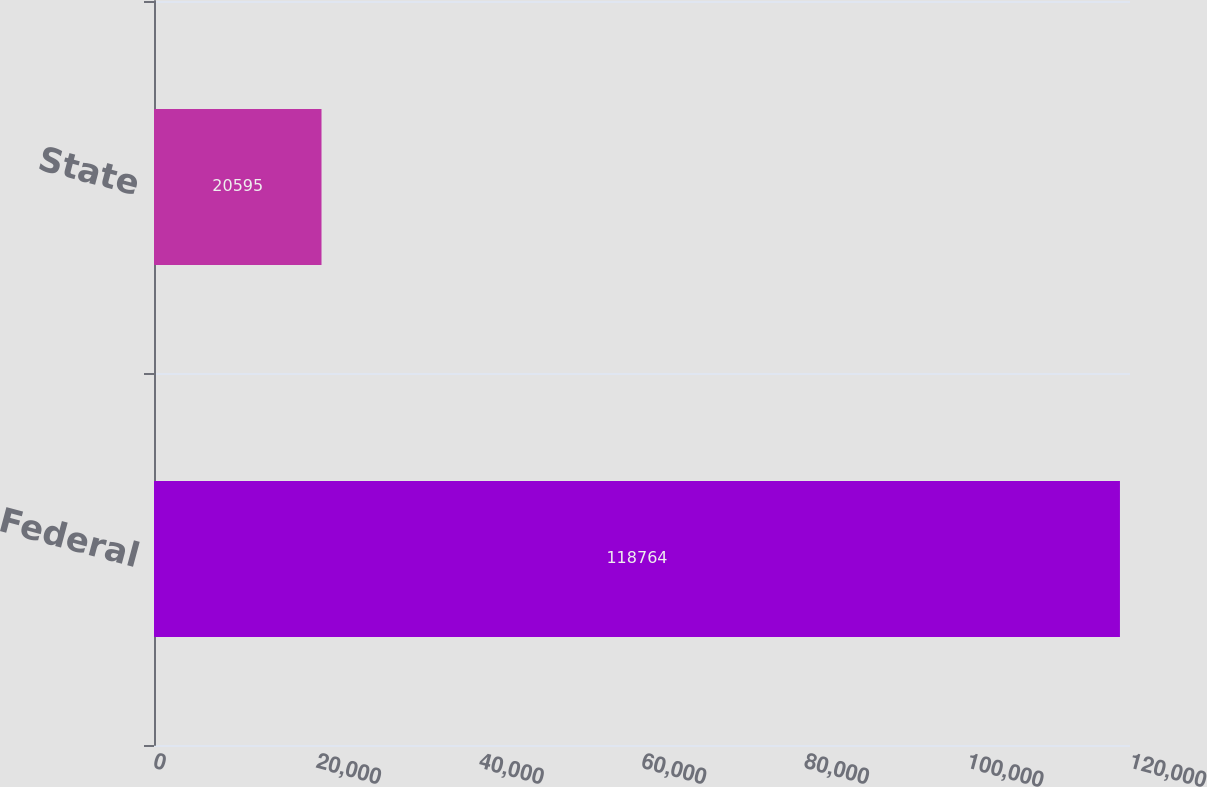Convert chart to OTSL. <chart><loc_0><loc_0><loc_500><loc_500><bar_chart><fcel>Federal<fcel>State<nl><fcel>118764<fcel>20595<nl></chart> 